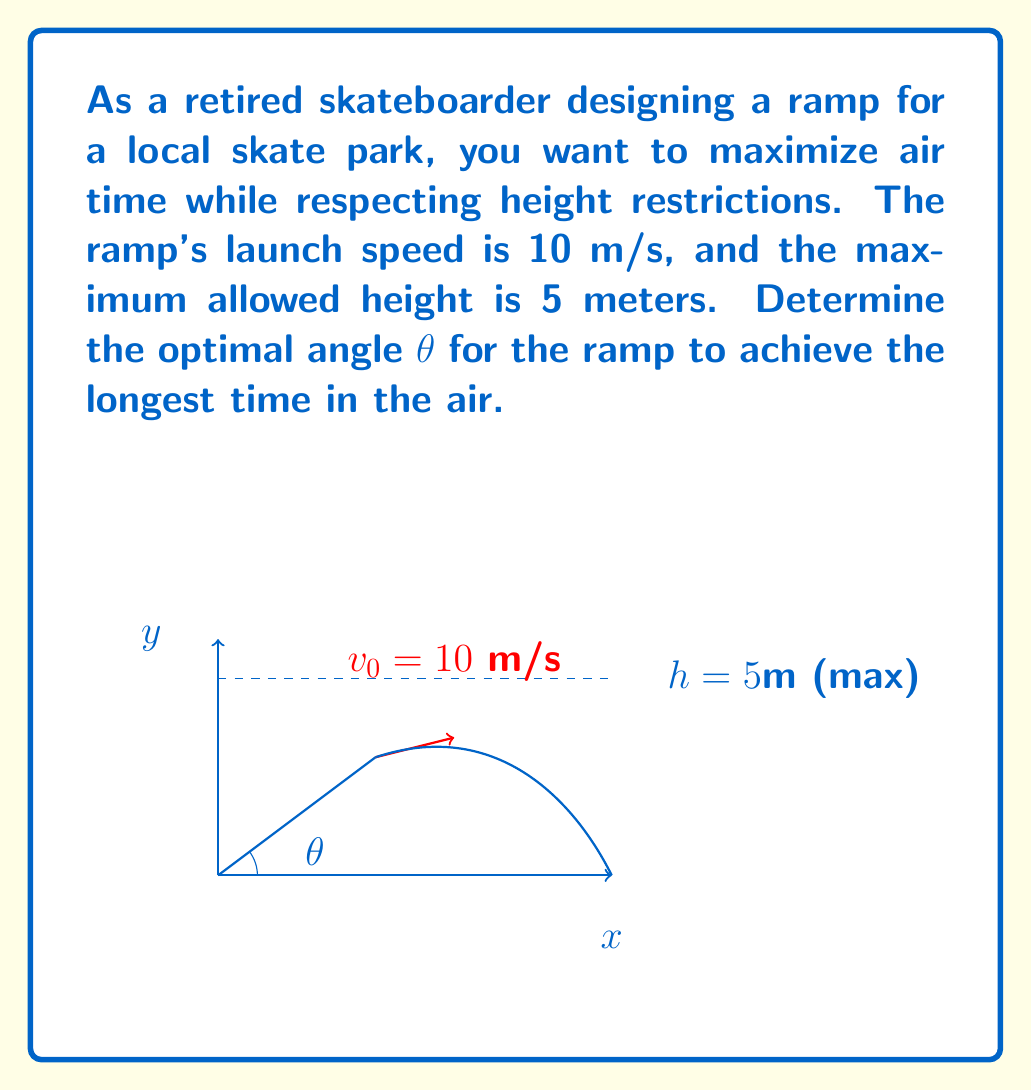Help me with this question. To solve this problem, we'll use the equations of motion for projectile motion and optimize for maximum time in the air.

1) The time of flight for a projectile launched at angle θ with initial velocity $v_0$ is given by:

   $$t = \frac{2v_0 \sin(\theta)}{g}$$

   where $g$ is the acceleration due to gravity (9.8 m/s²).

2) We want to maximize this time, but we're constrained by the maximum height. The maximum height reached by the projectile is:

   $$h = \frac{v_0^2 \sin^2(\theta)}{2g}$$

3) We're given that the maximum allowed height is 5 meters, so:

   $$5 = \frac{10^2 \sin^2(\theta)}{2(9.8)}$$

4) Solving this equation:

   $$\sin^2(\theta) = \frac{2(5)(9.8)}{10^2} = 0.98$$
   $$\sin(\theta) = \sqrt{0.98} = 0.99$$
   $$\theta = \arcsin(0.99) \approx 81.9°$$

5) This is the angle that will achieve the maximum allowed height of 5 meters, and consequently, the maximum time in the air.

6) We can verify by calculating the time:

   $$t = \frac{2(10) \sin(81.9°)}{9.8} \approx 2.02 \text{ seconds}$$

This is indeed the maximum time possible given the height constraint.
Answer: $81.9°$ 